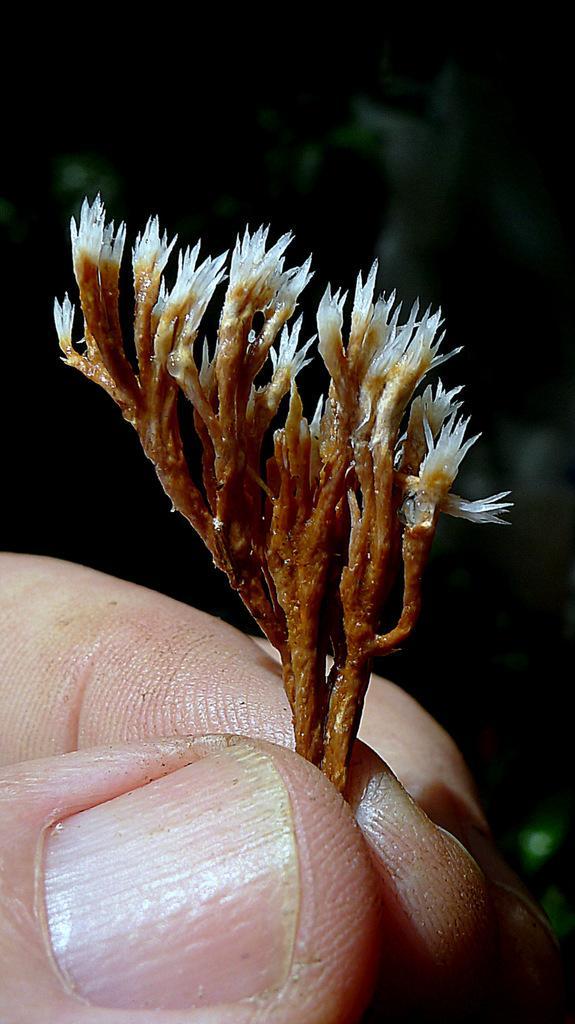Could you give a brief overview of what you see in this image? In this image we can see the fingers of a person and holding flowers. The background is dark. 